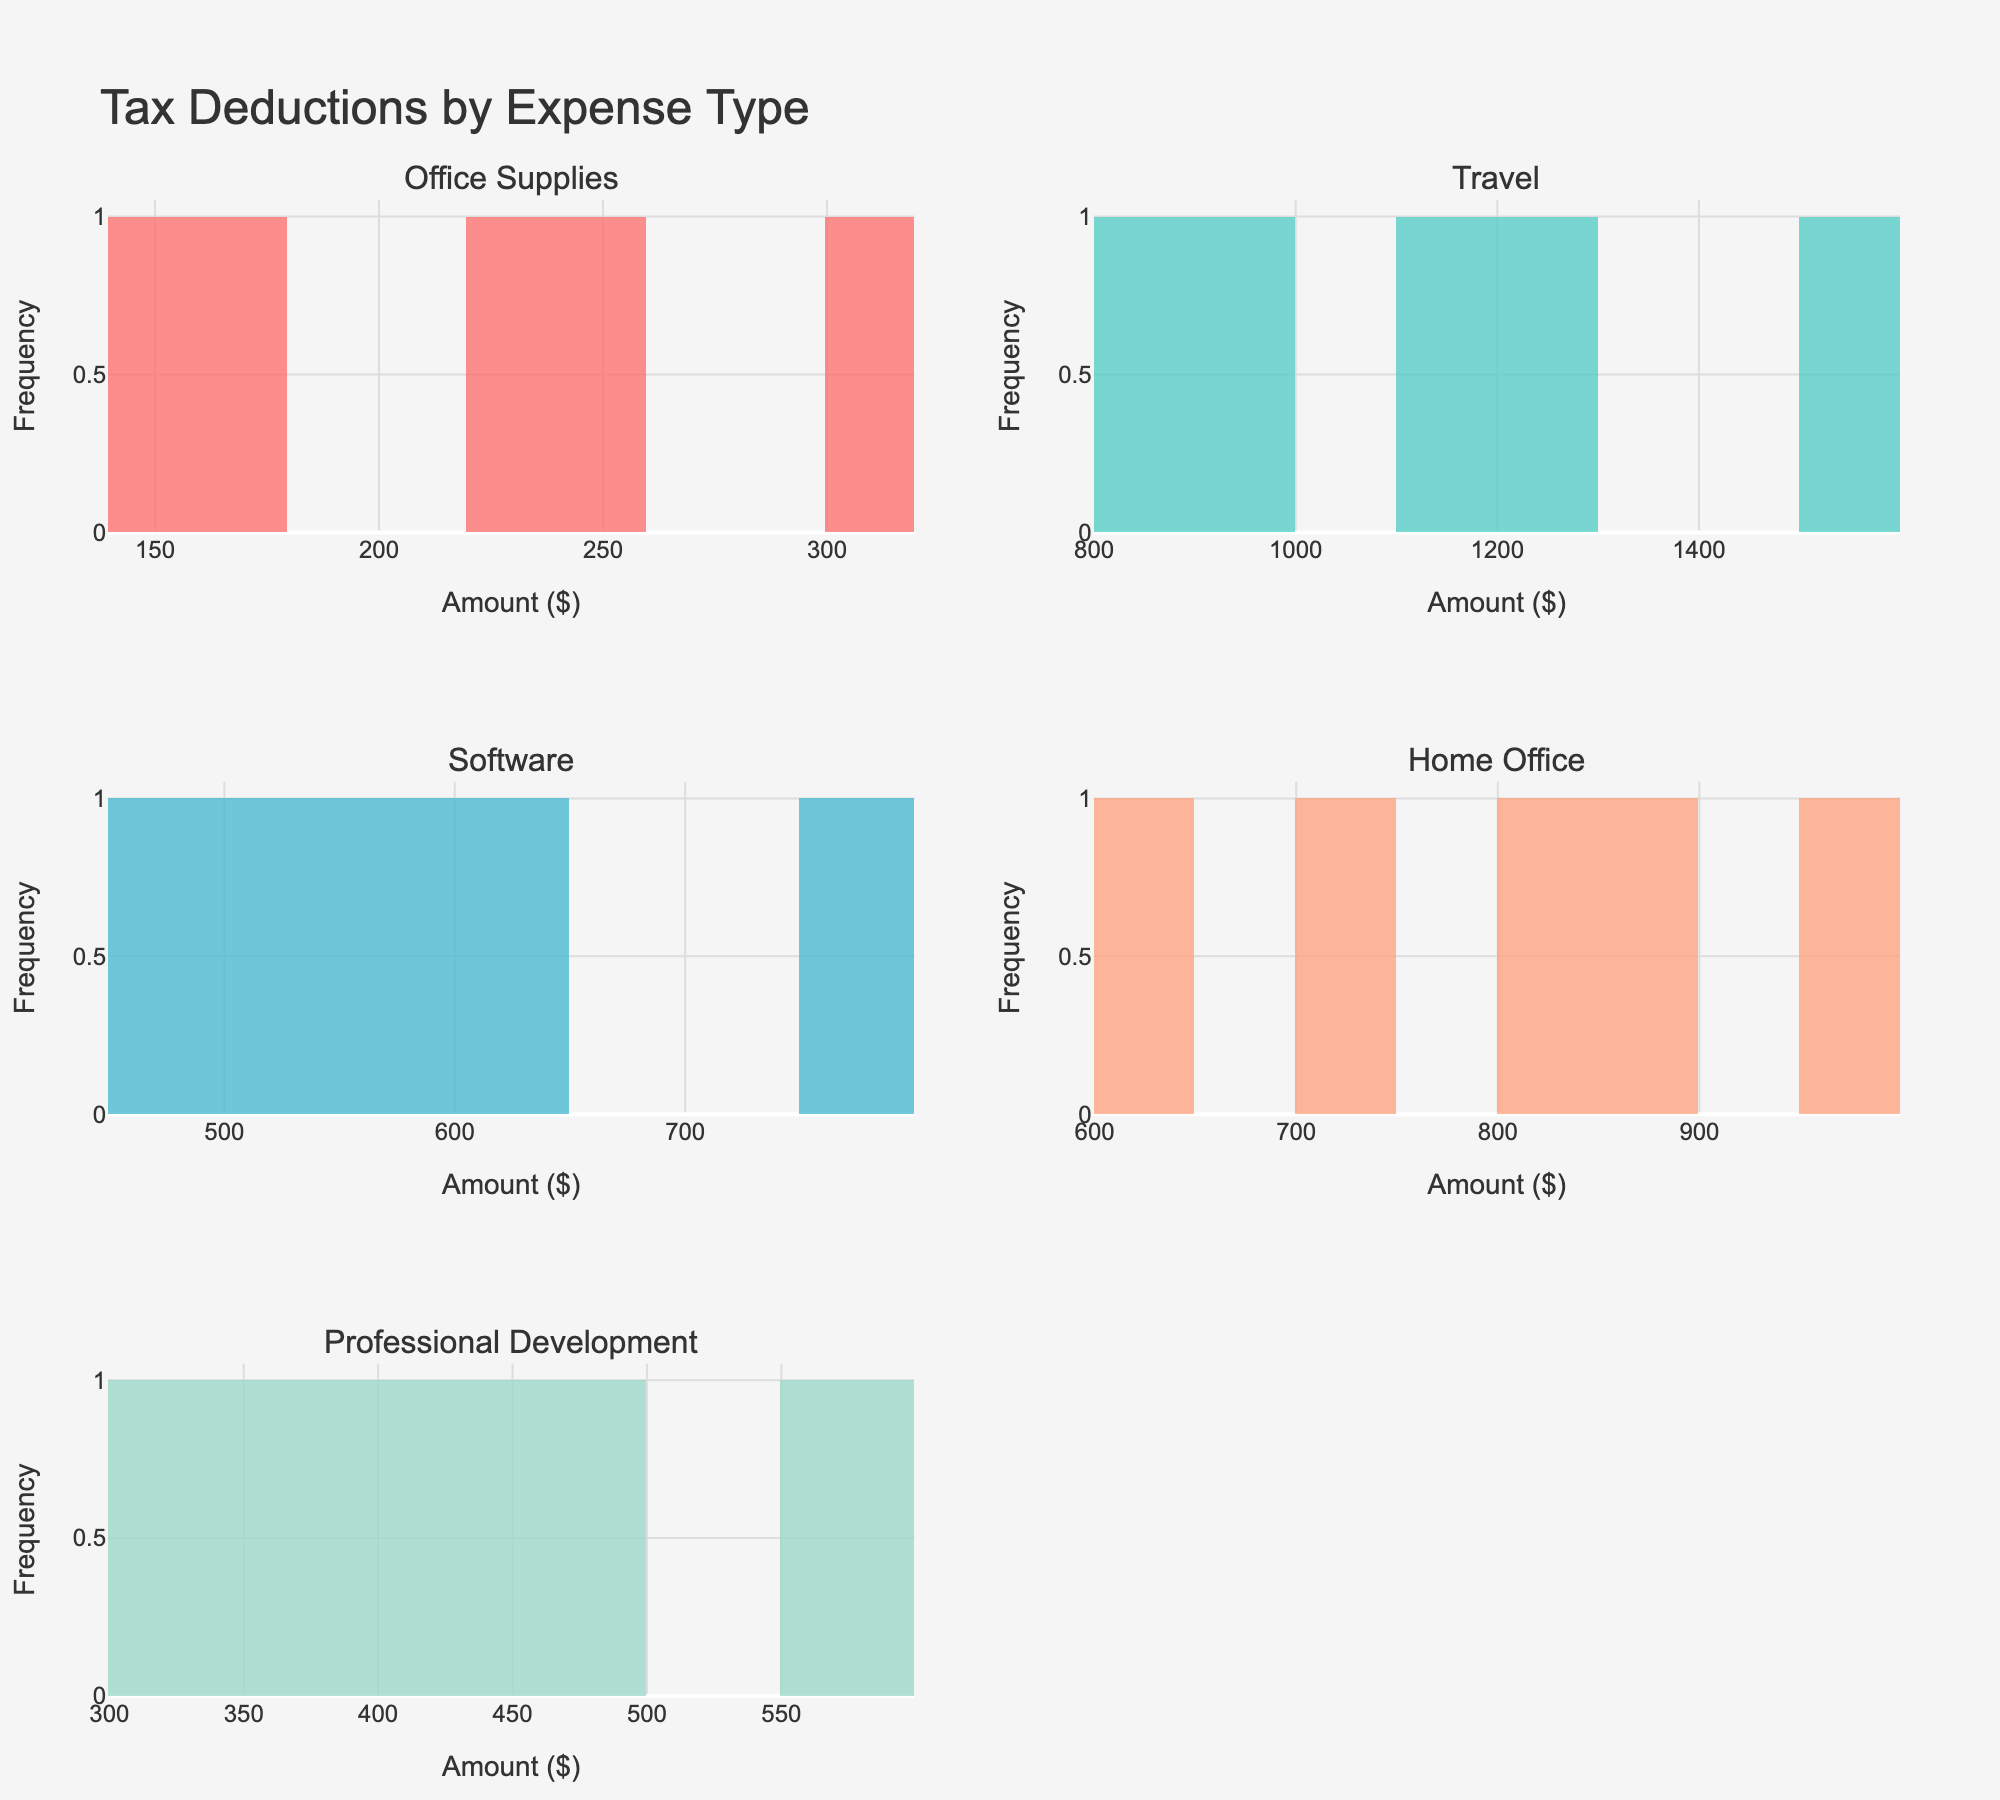Which expense type shows the highest frequency of tax deductions for the range of $300-$400? By observing the histogram for each expense type, we can see the frequencies for different ranges. The expense type with the highest frequency of tax deductions in the $300-$400 range can be identified.
Answer: Office Supplies How many tax deduction entries are there for Software expenses? We count the bars in the Software histogram, each representing a frequency corresponding to ranges of deduction amounts. The total number of entries is the sum of these frequencies.
Answer: 5 What is the median amount claimed for Professional Development expenses? To find the median, the values must be ordered, and the middle value (or the average of the two middle values) needs to be identified if there is an odd (or even) number of entries. The median is the value at the midpoint of the distribution.
Answer: 400 Which expense type has the most entries above $1000? By looking at each histogram and counting the entries (bars above the $1000 mark), we can determine the expense type with the most entries above $1000.
Answer: Travel Compare the distribution shapes of Office Supplies and Home Office expenses. Which one is more spread out? By comparing the spread and range of the bars in the histograms for Office Supplies and Home Office expenses, we can determine which distribution has more variability.
Answer: Travel What expense type has a peak at around $500? By examining the histograms, we can see which expense type has a distinct peak in frequency around the $500 range.
Answer: Software For Office Supplies, what is the common range (the mode) for the deductibility claims? The common range for Office Supplies can be identified by the highest bar (mode) in its histogram.
Answer: $200-$300 How does the frequency of claims for Office Supplies between $200 and $300 compare to similar ranges in Travel expenses? By comparing the height of the histogram bars in the $200-$300 range for both Office Supplies and Travel, we can see the difference in frequencies.
Answer: Higher for Office Supplies Which expense category has the lowest maximum claim? By identifying the highest value on the x-axis of each histogram, we can determine which category has the smallest maximum claim.
Answer: Software What is the average claim amount for Travel expenses? The average claim amount is calculated by summing all Travel expense amounts and dividing by the number of Travel claims. Specifically: (1200 + 800 + 1500 + 950 + 1100) / 5.
Answer: $1110 